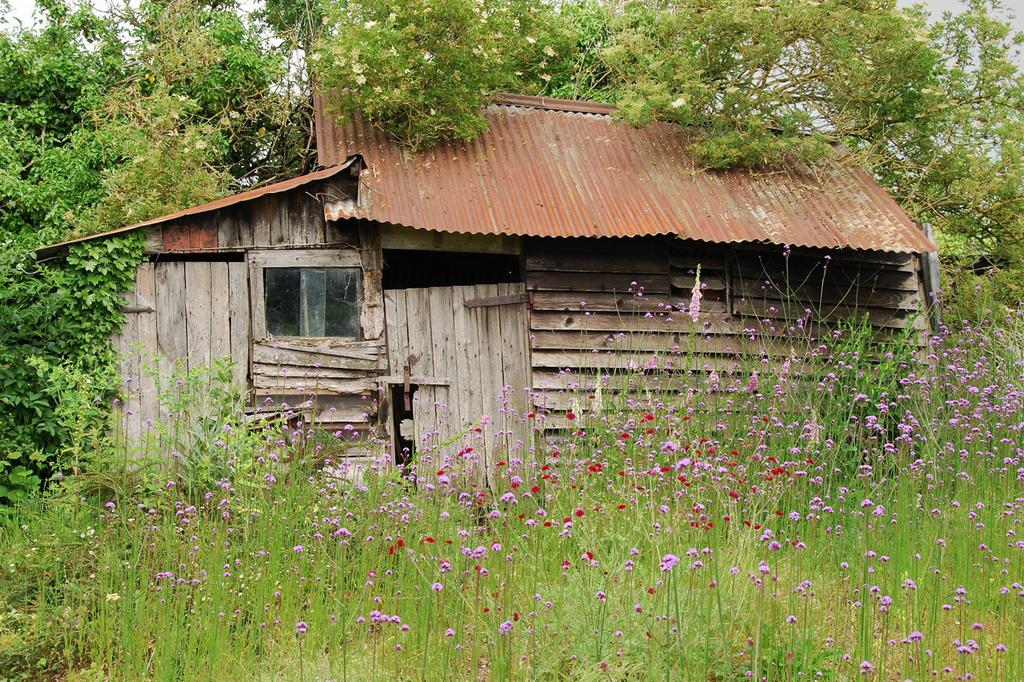What material is the house in the image made of? The house in the image is made of wood. What are the access points on the house? There are doors on the house. Is there any opening for light and ventilation in the house? Yes, there is a window on the house. What type of vegetation can be seen in the image? There are plants with flowers and trees with branches and leaves in the image. What new system was discovered in the image? There is no mention of a system or discovery in the image; it features a wooden house with doors, a window, and vegetation. 